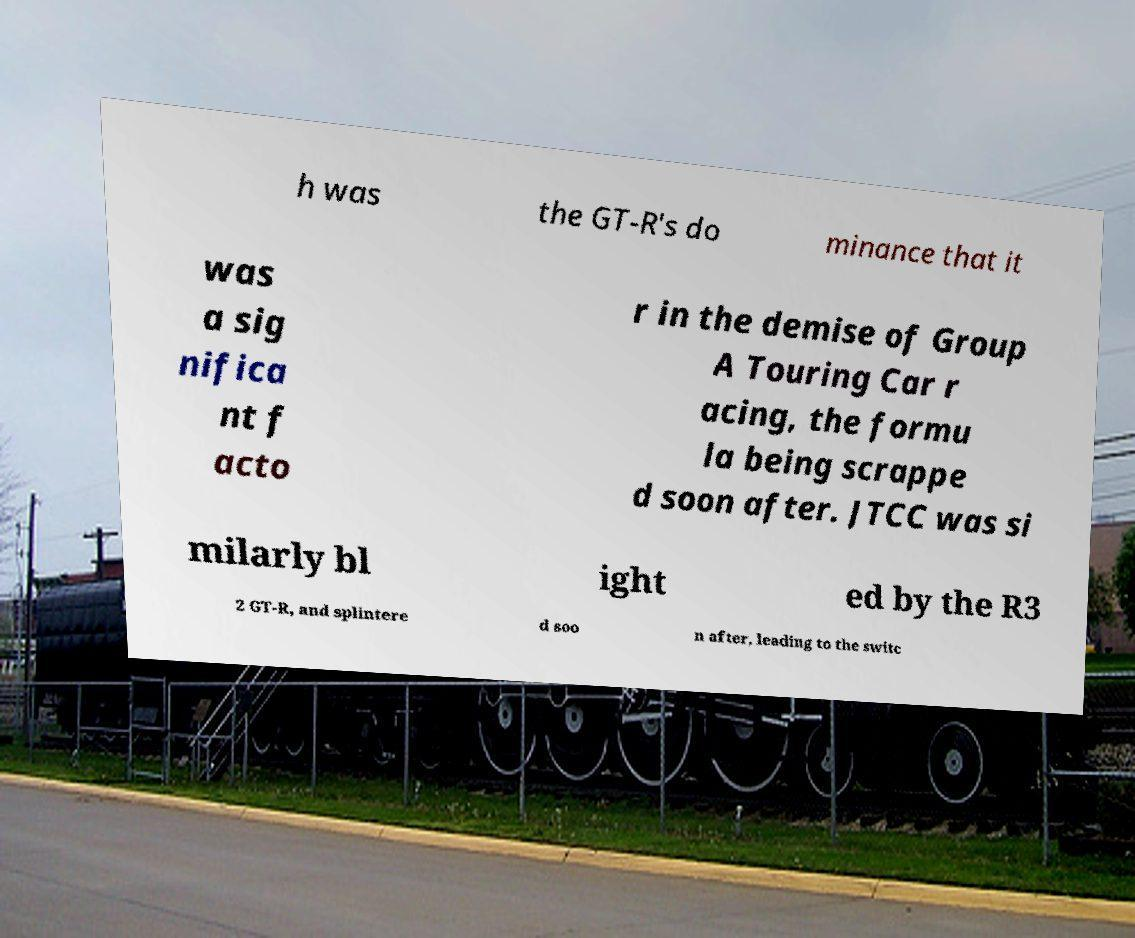There's text embedded in this image that I need extracted. Can you transcribe it verbatim? h was the GT-R's do minance that it was a sig nifica nt f acto r in the demise of Group A Touring Car r acing, the formu la being scrappe d soon after. JTCC was si milarly bl ight ed by the R3 2 GT-R, and splintere d soo n after, leading to the switc 